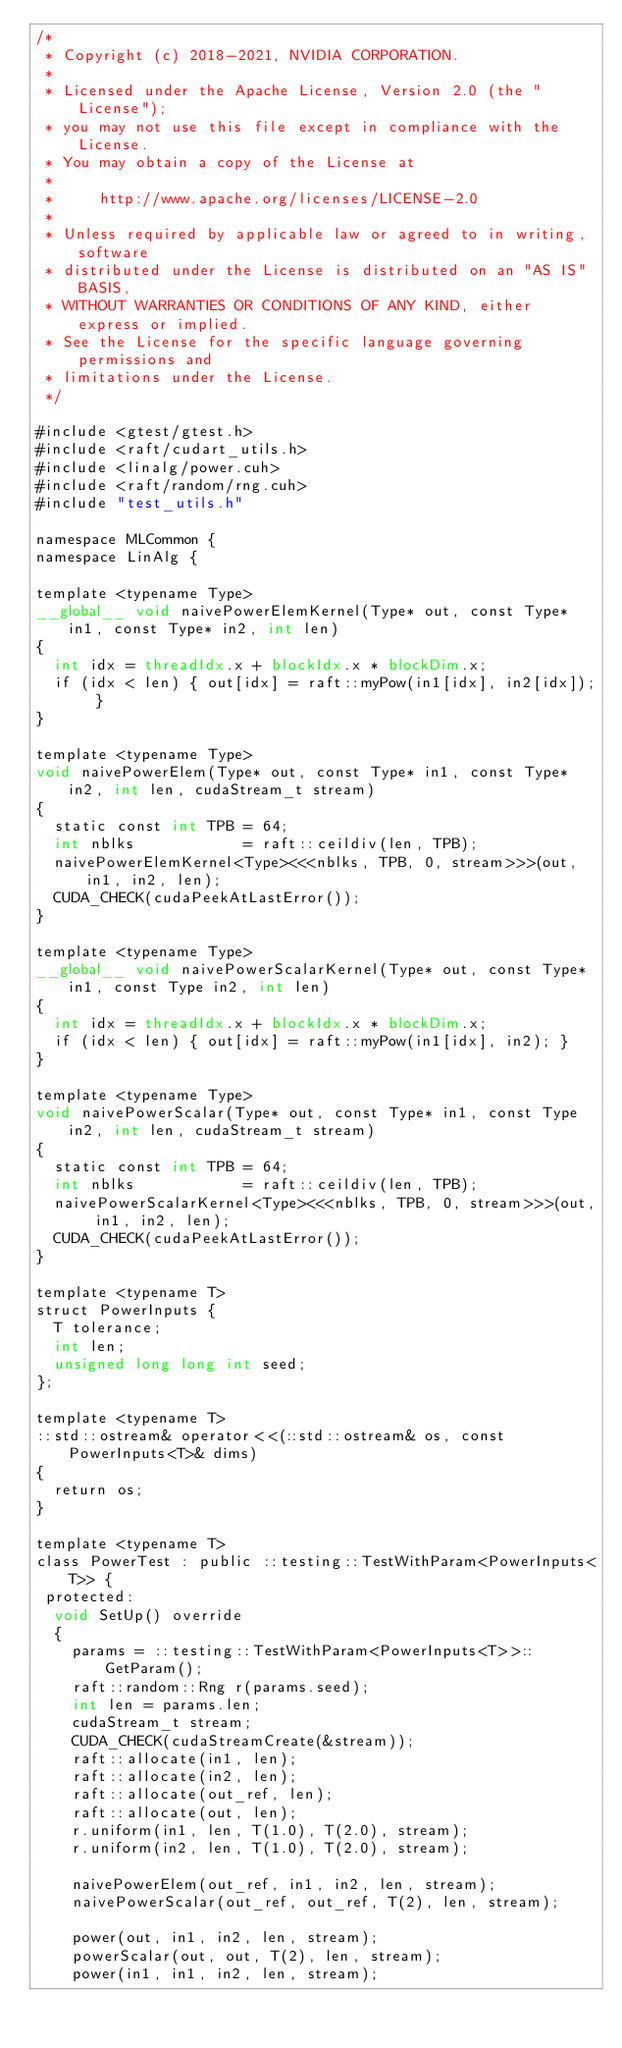Convert code to text. <code><loc_0><loc_0><loc_500><loc_500><_Cuda_>/*
 * Copyright (c) 2018-2021, NVIDIA CORPORATION.
 *
 * Licensed under the Apache License, Version 2.0 (the "License");
 * you may not use this file except in compliance with the License.
 * You may obtain a copy of the License at
 *
 *     http://www.apache.org/licenses/LICENSE-2.0
 *
 * Unless required by applicable law or agreed to in writing, software
 * distributed under the License is distributed on an "AS IS" BASIS,
 * WITHOUT WARRANTIES OR CONDITIONS OF ANY KIND, either express or implied.
 * See the License for the specific language governing permissions and
 * limitations under the License.
 */

#include <gtest/gtest.h>
#include <raft/cudart_utils.h>
#include <linalg/power.cuh>
#include <raft/random/rng.cuh>
#include "test_utils.h"

namespace MLCommon {
namespace LinAlg {

template <typename Type>
__global__ void naivePowerElemKernel(Type* out, const Type* in1, const Type* in2, int len)
{
  int idx = threadIdx.x + blockIdx.x * blockDim.x;
  if (idx < len) { out[idx] = raft::myPow(in1[idx], in2[idx]); }
}

template <typename Type>
void naivePowerElem(Type* out, const Type* in1, const Type* in2, int len, cudaStream_t stream)
{
  static const int TPB = 64;
  int nblks            = raft::ceildiv(len, TPB);
  naivePowerElemKernel<Type><<<nblks, TPB, 0, stream>>>(out, in1, in2, len);
  CUDA_CHECK(cudaPeekAtLastError());
}

template <typename Type>
__global__ void naivePowerScalarKernel(Type* out, const Type* in1, const Type in2, int len)
{
  int idx = threadIdx.x + blockIdx.x * blockDim.x;
  if (idx < len) { out[idx] = raft::myPow(in1[idx], in2); }
}

template <typename Type>
void naivePowerScalar(Type* out, const Type* in1, const Type in2, int len, cudaStream_t stream)
{
  static const int TPB = 64;
  int nblks            = raft::ceildiv(len, TPB);
  naivePowerScalarKernel<Type><<<nblks, TPB, 0, stream>>>(out, in1, in2, len);
  CUDA_CHECK(cudaPeekAtLastError());
}

template <typename T>
struct PowerInputs {
  T tolerance;
  int len;
  unsigned long long int seed;
};

template <typename T>
::std::ostream& operator<<(::std::ostream& os, const PowerInputs<T>& dims)
{
  return os;
}

template <typename T>
class PowerTest : public ::testing::TestWithParam<PowerInputs<T>> {
 protected:
  void SetUp() override
  {
    params = ::testing::TestWithParam<PowerInputs<T>>::GetParam();
    raft::random::Rng r(params.seed);
    int len = params.len;
    cudaStream_t stream;
    CUDA_CHECK(cudaStreamCreate(&stream));
    raft::allocate(in1, len);
    raft::allocate(in2, len);
    raft::allocate(out_ref, len);
    raft::allocate(out, len);
    r.uniform(in1, len, T(1.0), T(2.0), stream);
    r.uniform(in2, len, T(1.0), T(2.0), stream);

    naivePowerElem(out_ref, in1, in2, len, stream);
    naivePowerScalar(out_ref, out_ref, T(2), len, stream);

    power(out, in1, in2, len, stream);
    powerScalar(out, out, T(2), len, stream);
    power(in1, in1, in2, len, stream);</code> 